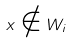Convert formula to latex. <formula><loc_0><loc_0><loc_500><loc_500>x \notin W _ { i }</formula> 